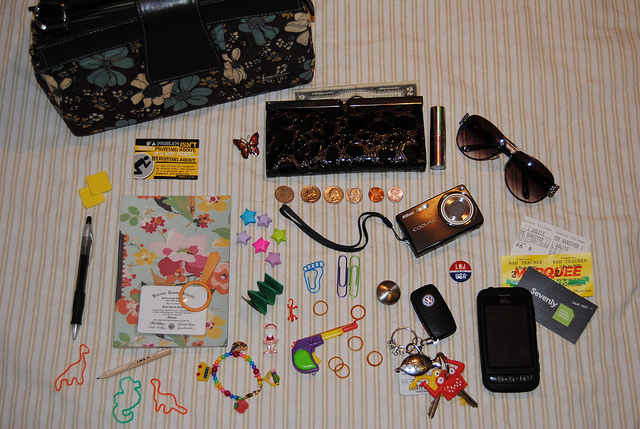Can you tell me what the theme of this collection of items might be? This collection of items suggests a theme centered around everyday personal belongings that one might carry in their purse or pockets. The objects include practical items such as keys, sunglasses, and a wallet, as well as decorative and personalized items like jewelry and a beaded bracelet, possibly reflecting individual taste and lifestyle. 